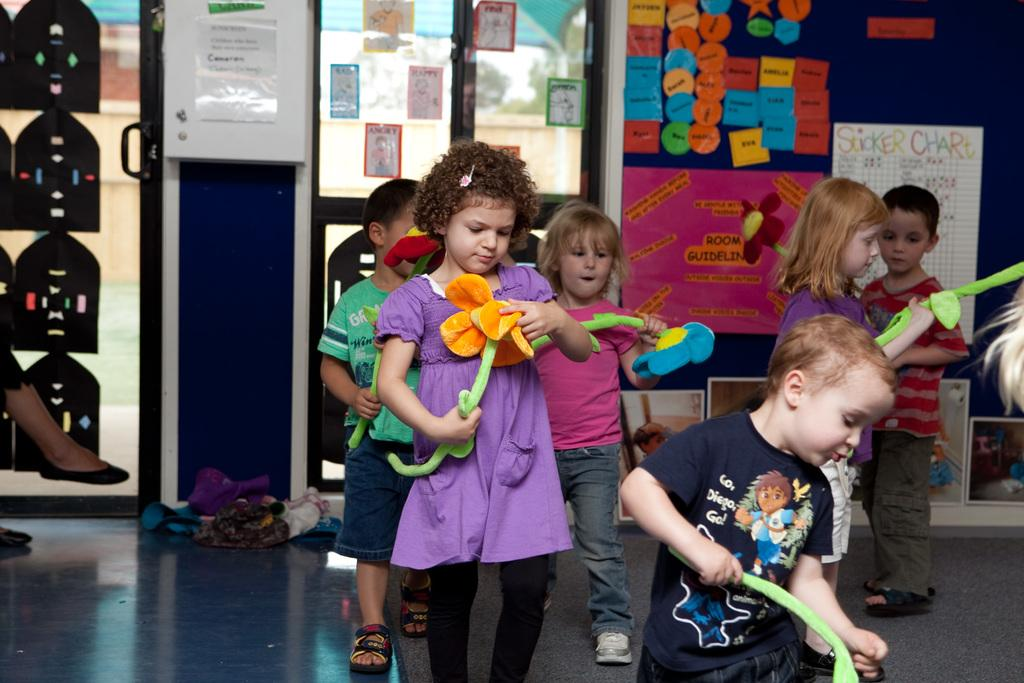How many kids are in the image? There are kids in the image, but the exact number is not specified. What are the kids doing in the image? The kids are standing on the floor and playing with toys. What can be seen in the background of the image? There is a wall in the background of the image. What is on the wall in the image? The wall has sticky notes and charts on it. What type of army is depicted on the wall in the image? There is no army depicted on the wall in the image; it has sticky notes and charts on it. Are the kids wearing masks in the image? The provided facts do not mention anything about masks, so we cannot determine if the kids are wearing masks in the image. 